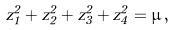Convert formula to latex. <formula><loc_0><loc_0><loc_500><loc_500>z _ { 1 } ^ { 2 } + z _ { 2 } ^ { 2 } + z _ { 3 } ^ { 2 } + z _ { 4 } ^ { 2 } = \mu \, ,</formula> 